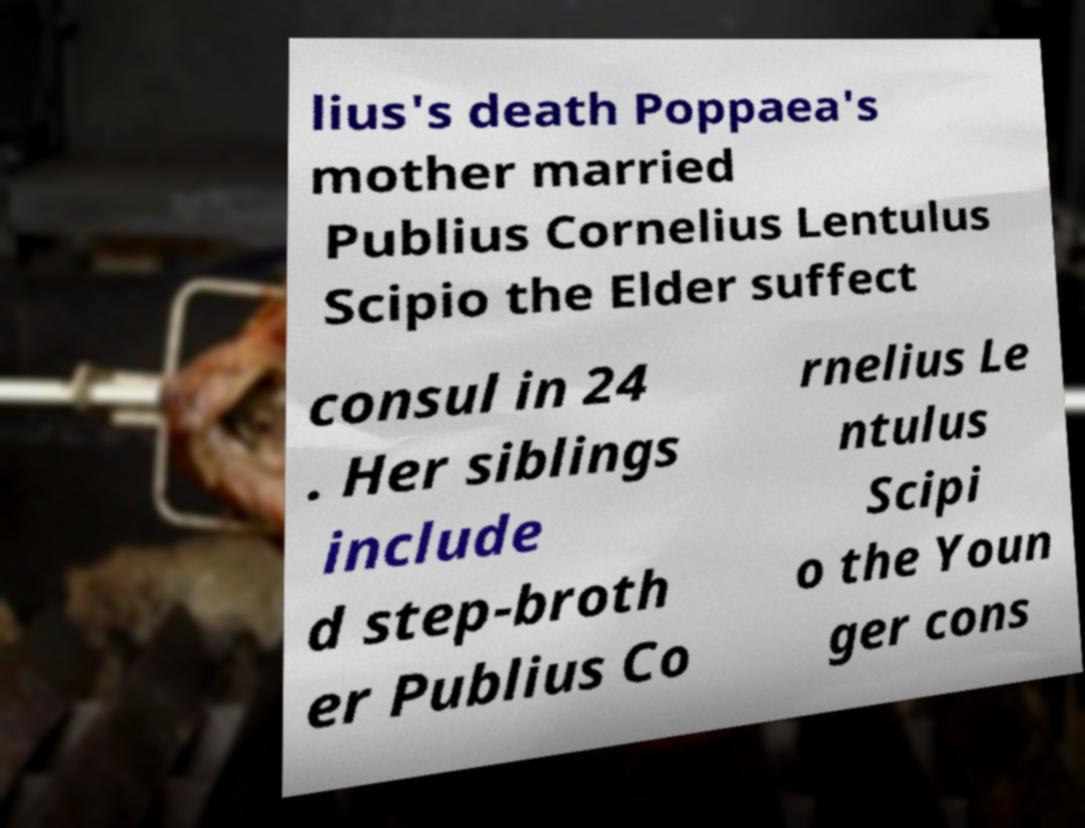There's text embedded in this image that I need extracted. Can you transcribe it verbatim? lius's death Poppaea's mother married Publius Cornelius Lentulus Scipio the Elder suffect consul in 24 . Her siblings include d step-broth er Publius Co rnelius Le ntulus Scipi o the Youn ger cons 